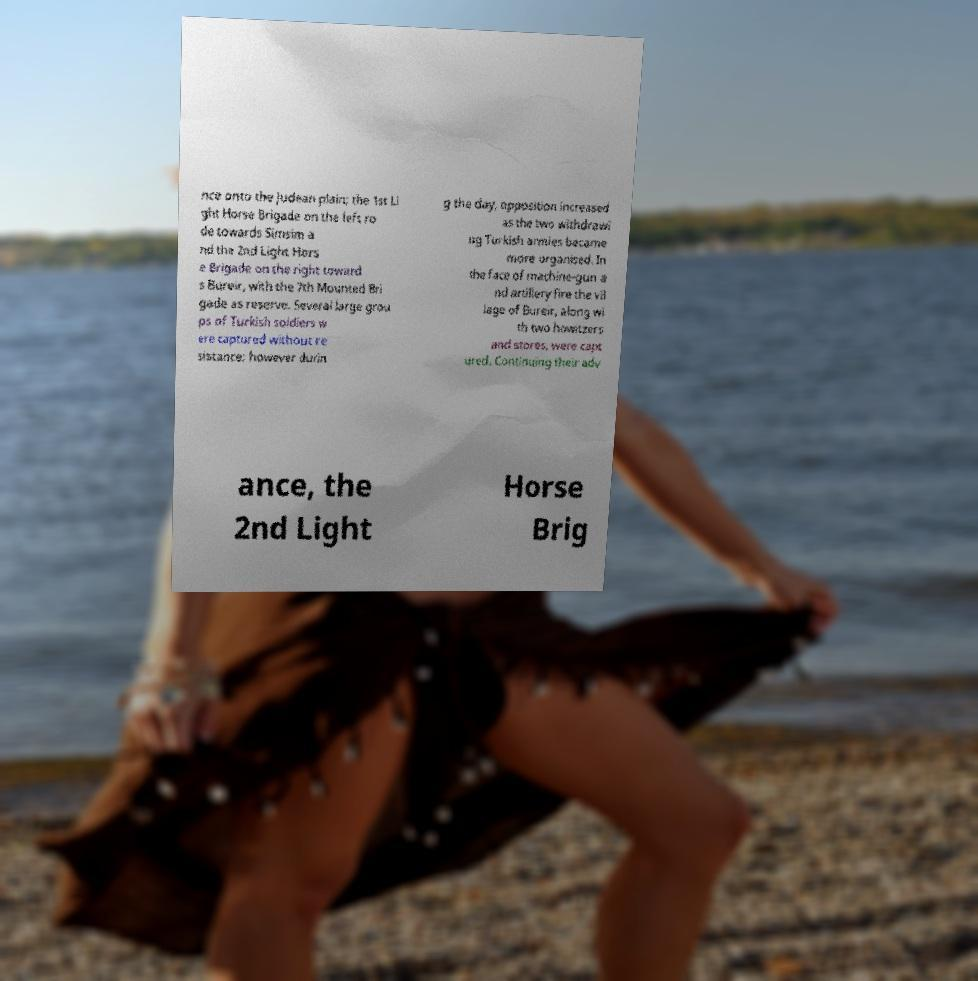What messages or text are displayed in this image? I need them in a readable, typed format. nce onto the Judean plain; the 1st Li ght Horse Brigade on the left ro de towards Simsim a nd the 2nd Light Hors e Brigade on the right toward s Bureir, with the 7th Mounted Bri gade as reserve. Several large grou ps of Turkish soldiers w ere captured without re sistance; however durin g the day, opposition increased as the two withdrawi ng Turkish armies became more organised. In the face of machine-gun a nd artillery fire the vil lage of Bureir, along wi th two howitzers and stores, were capt ured. Continuing their adv ance, the 2nd Light Horse Brig 